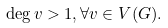<formula> <loc_0><loc_0><loc_500><loc_500>\deg v > 1 , \forall v \in V ( G ) .</formula> 